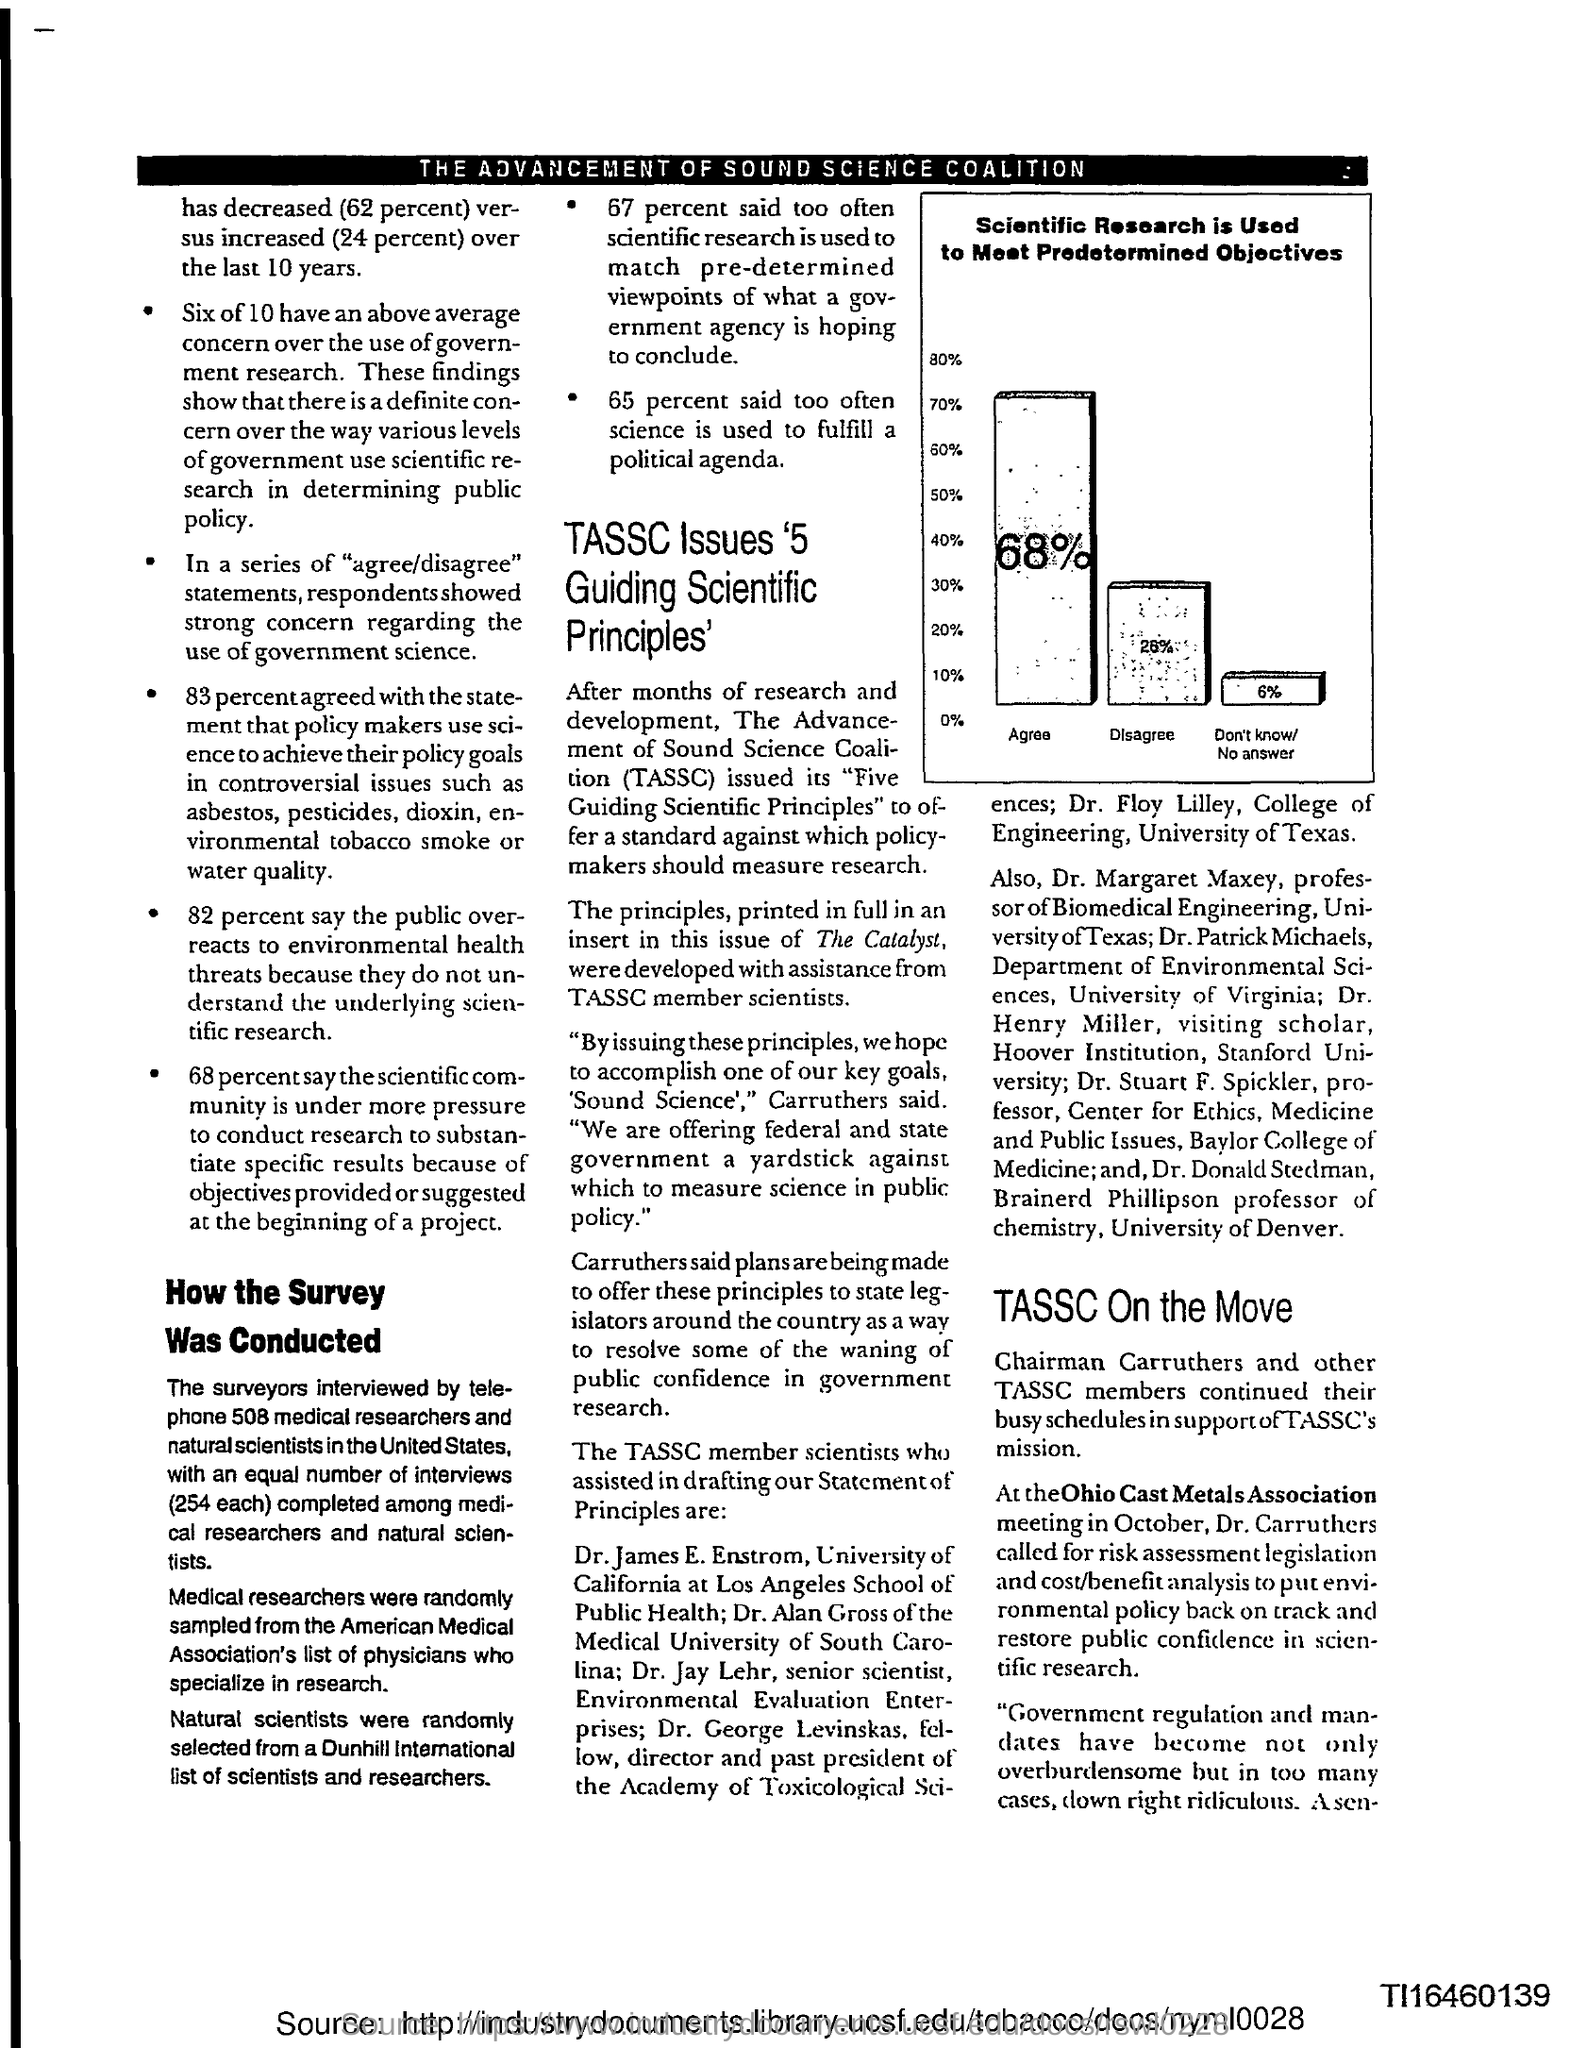What percent agree that Scientific Research is Used to Meet Predetermined Objectives?
Provide a succinct answer. 68%. What does TASSC denote?
Provide a short and direct response. THE ADVANCEMENT OF SOUND SCIENCE COALITION. What percent said too often science is used to fulfill a political agenda?
Give a very brief answer. 65. At which meeting did Dr. Carruthers call for risk assessment legislation?
Make the answer very short. Ohio Cast Metals Association. Who is the Chairman of TASSC?
Offer a terse response. Carruthers. 